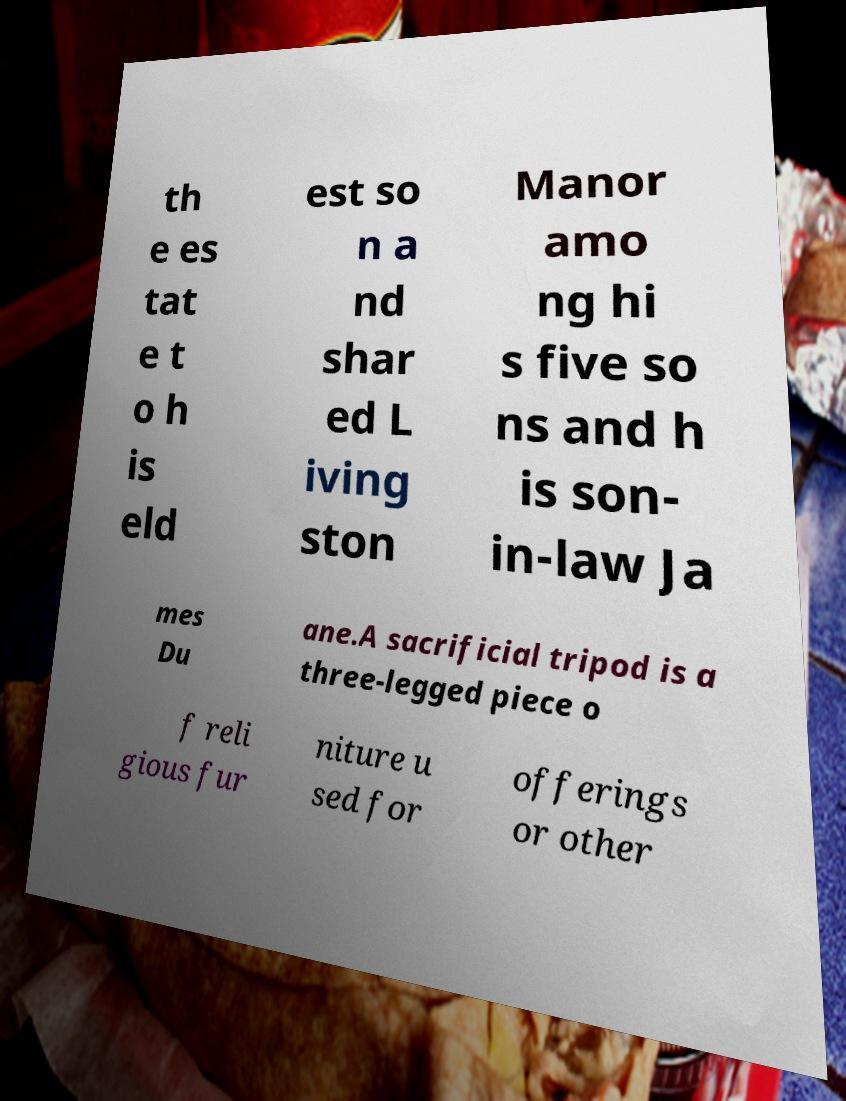What messages or text are displayed in this image? I need them in a readable, typed format. th e es tat e t o h is eld est so n a nd shar ed L iving ston Manor amo ng hi s five so ns and h is son- in-law Ja mes Du ane.A sacrificial tripod is a three-legged piece o f reli gious fur niture u sed for offerings or other 